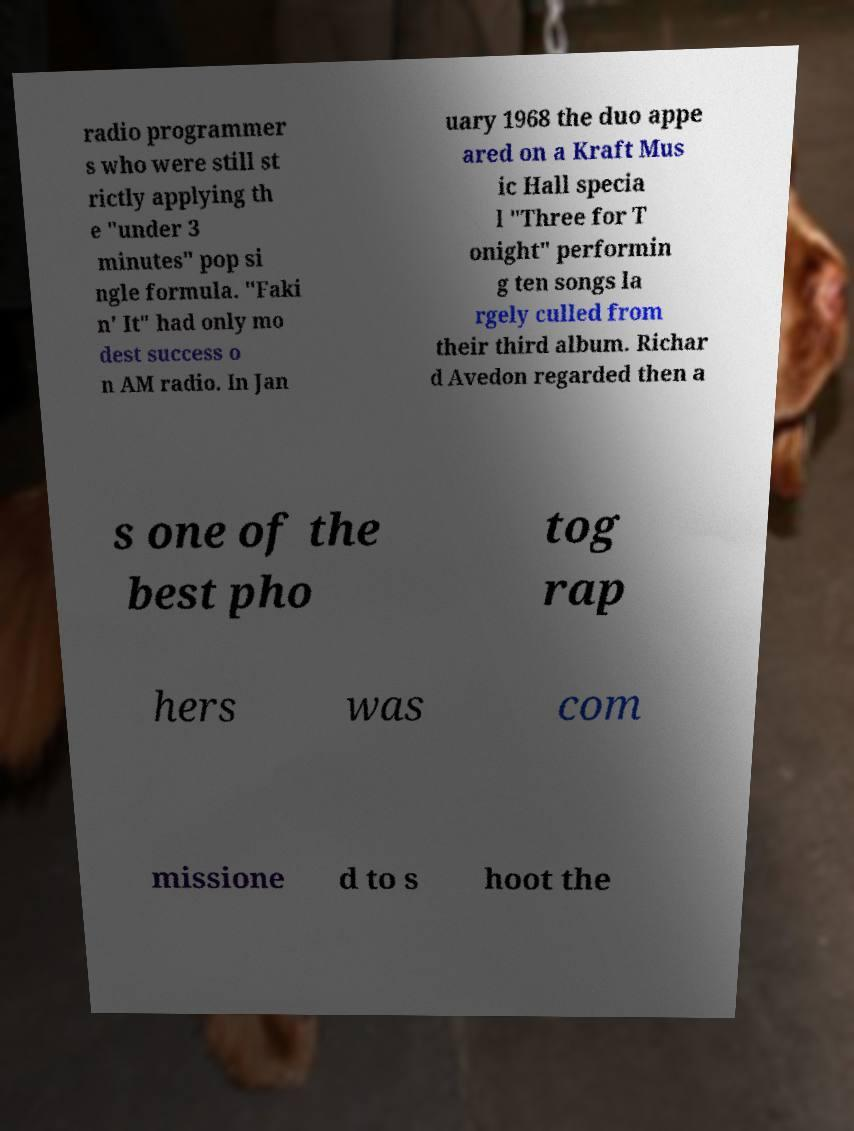Can you read and provide the text displayed in the image?This photo seems to have some interesting text. Can you extract and type it out for me? radio programmer s who were still st rictly applying th e "under 3 minutes" pop si ngle formula. "Faki n' It" had only mo dest success o n AM radio. In Jan uary 1968 the duo appe ared on a Kraft Mus ic Hall specia l "Three for T onight" performin g ten songs la rgely culled from their third album. Richar d Avedon regarded then a s one of the best pho tog rap hers was com missione d to s hoot the 